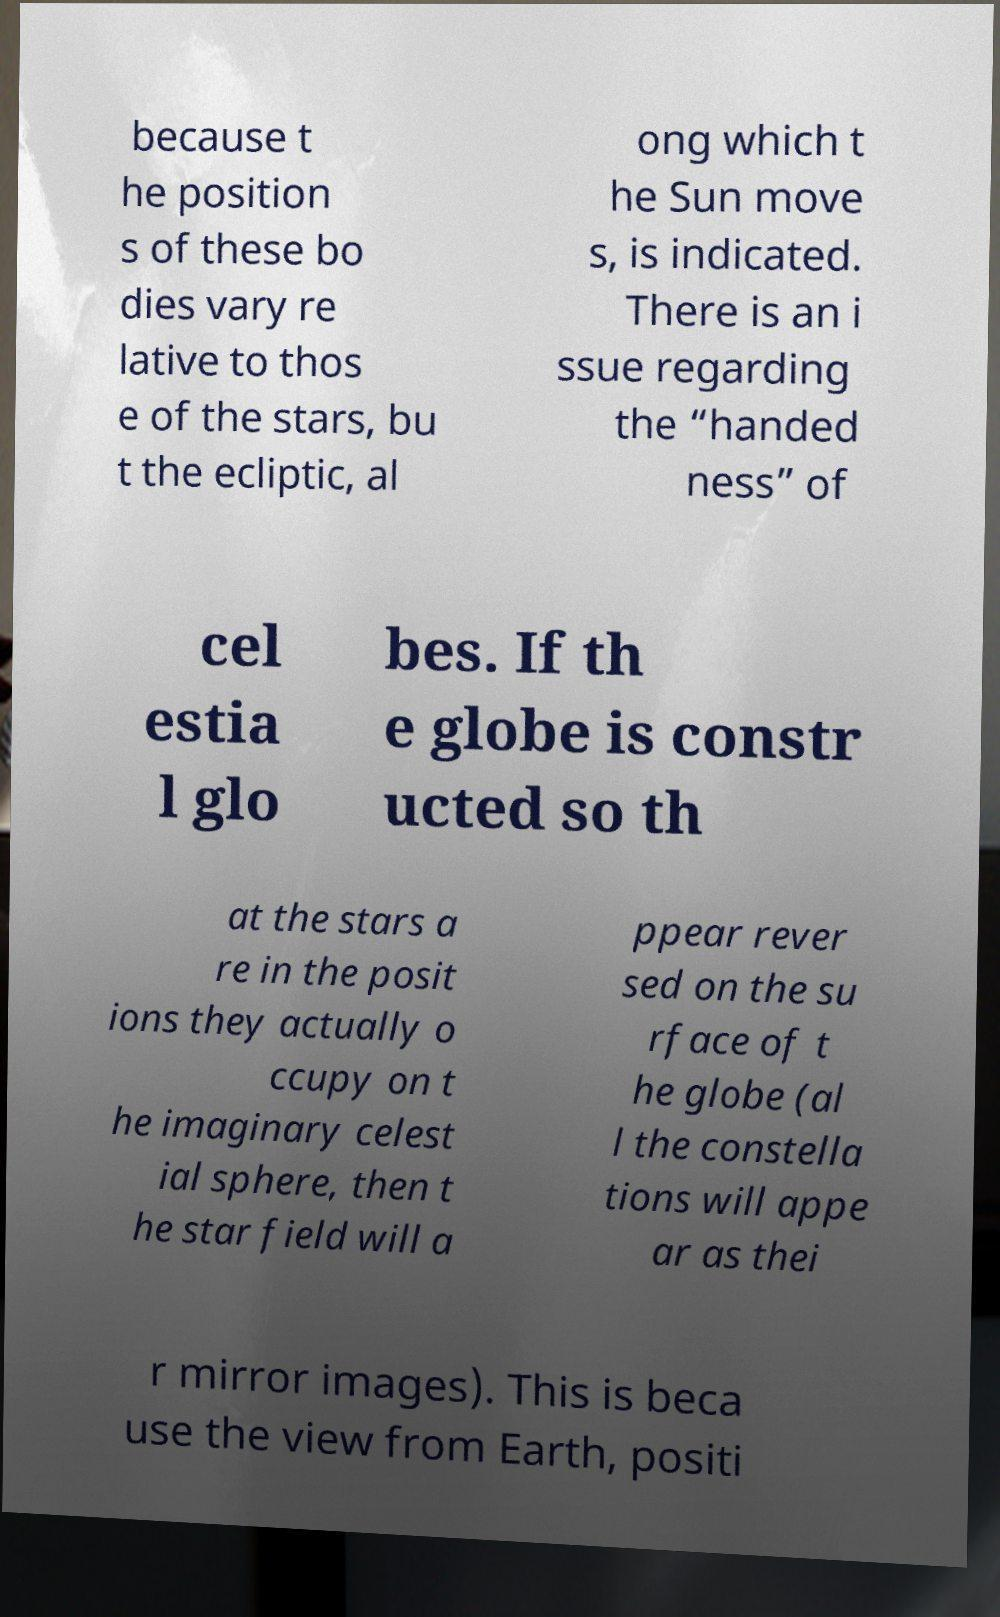There's text embedded in this image that I need extracted. Can you transcribe it verbatim? because t he position s of these bo dies vary re lative to thos e of the stars, bu t the ecliptic, al ong which t he Sun move s, is indicated. There is an i ssue regarding the “handed ness” of cel estia l glo bes. If th e globe is constr ucted so th at the stars a re in the posit ions they actually o ccupy on t he imaginary celest ial sphere, then t he star field will a ppear rever sed on the su rface of t he globe (al l the constella tions will appe ar as thei r mirror images). This is beca use the view from Earth, positi 